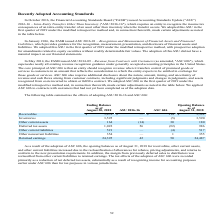According to Micron Technology's financial document, What does Accounting Standards Update ("ASU") 2016-16 – Intra-Entity Transfers Other Than Inventory ("ASU 2016-16") specify? requires an entity to recognize the income tax consequences of an intra-entity transfer of an asset other than inventory when the transfer occurs. The document states: "sfers Other Than Inventory ("ASU 2016-16"), which requires an entity to recognize the income tax consequences of an intra-entity transfer of an asset ..." Also, What is the opening balance for retained earnings as of August 31, 2018? According to the financial document, 24,487. The relevant text states: "Retained earnings 24,395 42 50 24,487..." Also, What were the effects of adopting ASU 2016-16 and ASC 606 for other current assets respectively? The document shows two values: (14) and 30. From the document: "Other current assets 164 (14) 30 180 Other current assets 164 (14) 30 180..." Also, can you calculate: What is the total opening balance for receivables and inventories as of August 31, 2018? Based on the calculation: 5,592+3,590 , the result is 9182. This is based on the information: "Receivables $ 5,478 $ — $ 114 $ 5,592 Inventories 3,595 — (5) 3,590..." The key data points involved are: 3,590, 5,592. Also, can you calculate: What is the ratio of ending balance as of August 30, 2018, for other current liabilities to other noncurrent liabilities? Based on the calculation: 521/354 , the result is 1.47. This is based on the information: "Other current liabilities 521 — (4) 517 Other noncurrent liabilities 354 — 1 355..." The key data points involved are: 354, 521. Also, can you calculate: What is the percentage change of opening balance as of August 31, 2018, from ending balance in August 30, 2018, for receivables due to the adoption of ASC 606? To answer this question, I need to perform calculations using the financial data. The calculation is: ($5,592-$5,478)/$5,478 , which equals 2.08 (percentage). This is based on the information: "Receivables $ 5,478 $ — $ 114 $ 5,592 Receivables $ 5,478 $ — $ 114 $ 5,592..." The key data points involved are: 5,478, 5,592. 